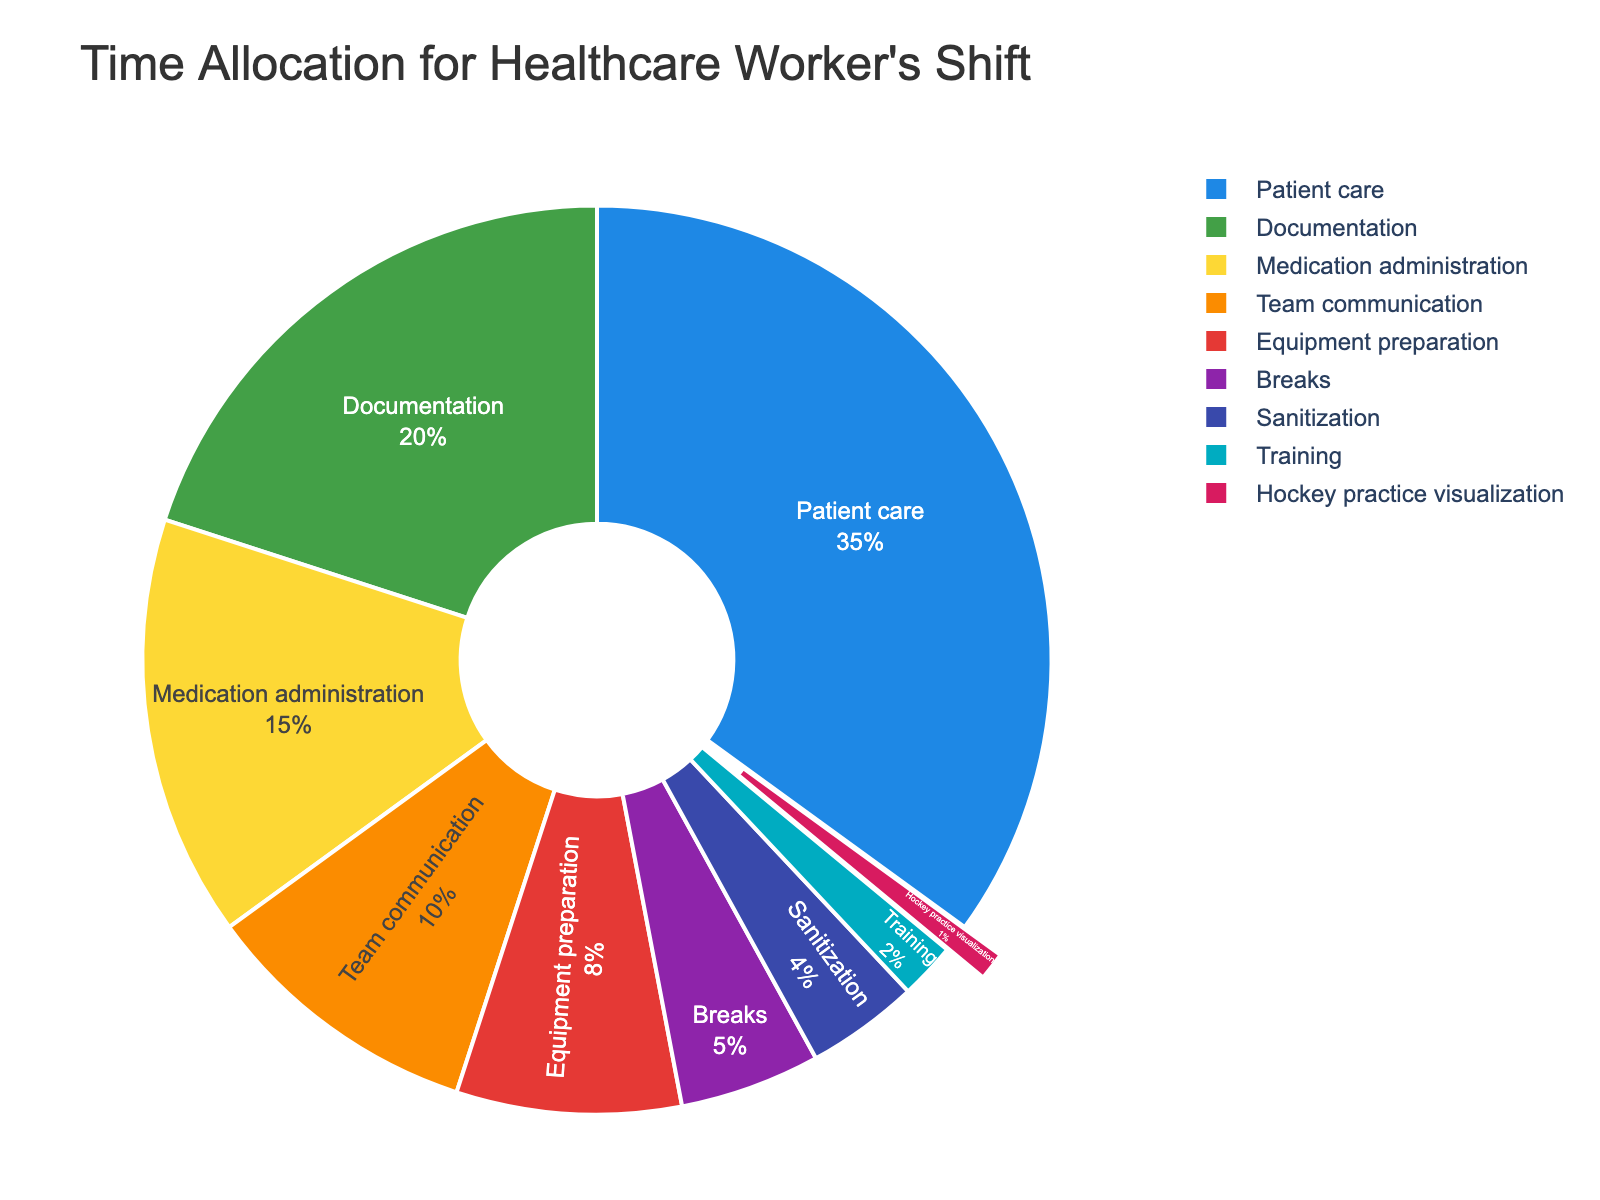What activity takes up the largest portion of time in a healthcare worker's shift? The largest portion of time can be identified by looking for the largest slice in the pie chart. Patient care occupies the largest slice, representing 35% of the time.
Answer: Patient care What is the combined percentage for Documentation and Medication administration? We need to sum the percentages of Documentation and Medication administration. Documentation is 20% and Medication administration is 15%, so 20% + 15% = 35%.
Answer: 35% Which activity spends less time, Team communication or Equipment preparation? To determine this, compare the percentage values for Team communication and Equipment preparation. Team communication is 10% whereas Equipment preparation is 8%. Hence, Equipment preparation spends less time.
Answer: Equipment preparation How much more time is allocated to Breaks compared to Sanitization? We need to find the difference between the percentage of time for Breaks and Sanitization. Breaks are 5% and Sanitization is 4%, so the difference is 5% - 4% = 1%.
Answer: 1% What activities combined occupy less time than Documentation alone? We sum the percentages of activities that individually are less than 20% (the percentage for Documentation). These activities are Equipment preparation (8%), Breaks (5%), Sanitization (4%), Training (2%), and Hockey practice visualization (1%). Adding these gives 8% + 5% + 4% + 2% + 1% = 20%. Since 20% is not less than 20%, we exclude Equipment preparation (8%) to get 5% + 4% + 2% + 1% = 12%.
Answer: Breaks, Sanitization, Training, Hockey practice visualization Is the percentage of time spent on Training and Hockey practice visualization combined less than the time spent on Decoration? To determine this, add the percentages of Training and Hockey practice visualization. Training is 2% and Hockey practice visualization is 1%, so their combined percentage is 2% + 1% = 3%. Documentation takes 20%. 3% is less than 20%.
Answer: Yes Which color represents Equipment preparation on the chart? The color for each activity is visually indicated and Equipment preparation is represented by a specific color. In this chart, Equipment preparation is represented by the red slice.
Answer: Red How many activities take up more than 10% of the time in the healthcare worker's shift? Activities exceeding 10% can be counted. Patient care (35%), Documentation (20%), and Medication administration (15%) each take up more than 10% of the time. Therefore, three activities take up more than 10% each.
Answer: 3 What percentage of time is taken up by activities other than Patient care, Documentation, and Medication administration? To find this, sum up the percentages of all activities other than the three mentioned. They are: Team communication (10%), Equipment preparation (8%), Breaks (5%), Sanitization (4%), Training (2%), and Hockey practice visualization (1%). Adding these gives 10% + 8% + 5% + 4% + 2% + 1% = 30%.
Answer: 30% How much time is allocated to activities other than Breaks, Training, and Hockey practice visualization? To find this, subtract the combined percentage of Breaks, Training, and Hockey practice visualization from 100%. Breaks are 5%, Training is 2%, and Hockey practice visualization is 1%, so their combined percentage is 5% + 2% + 1% = 8%. 100% - 8% = 92%.
Answer: 92% 